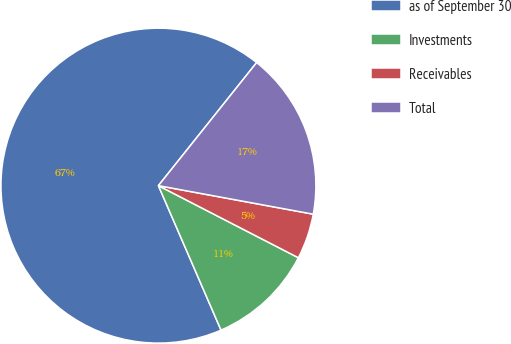Convert chart to OTSL. <chart><loc_0><loc_0><loc_500><loc_500><pie_chart><fcel>as of September 30<fcel>Investments<fcel>Receivables<fcel>Total<nl><fcel>67.23%<fcel>10.92%<fcel>4.67%<fcel>17.18%<nl></chart> 